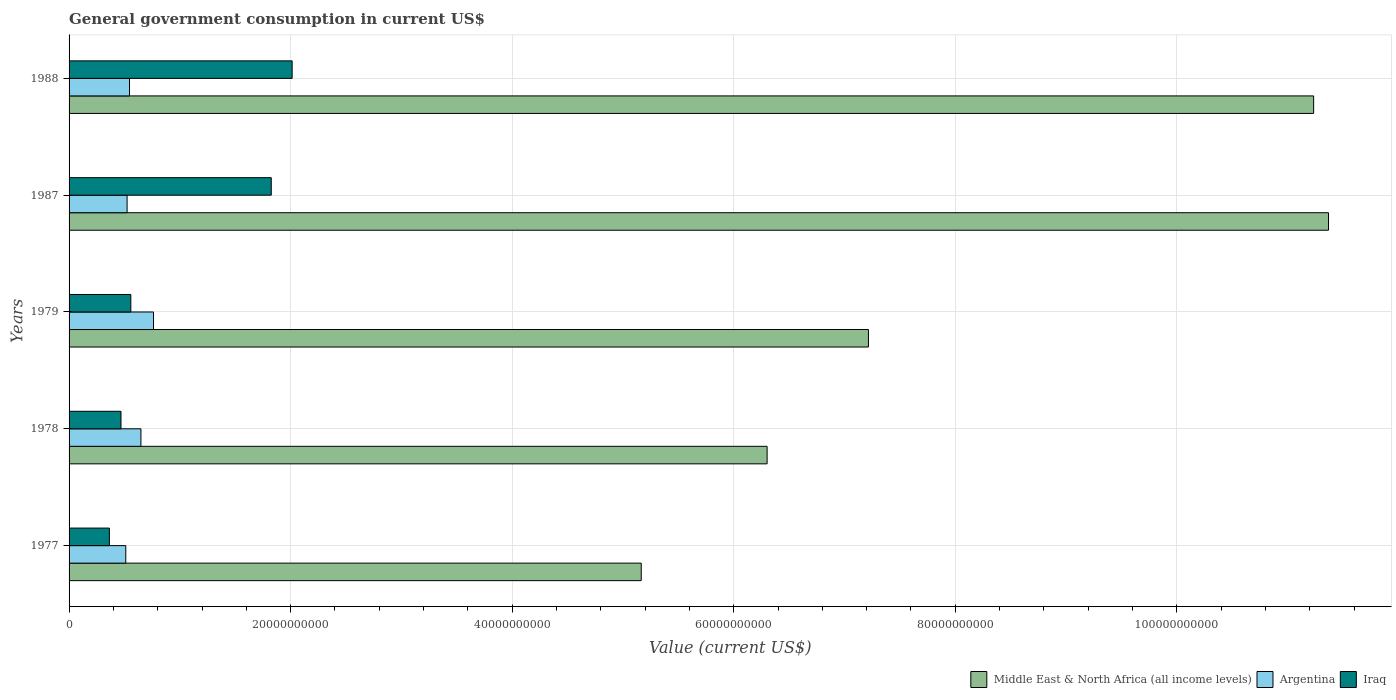How many different coloured bars are there?
Your answer should be compact. 3. Are the number of bars on each tick of the Y-axis equal?
Your response must be concise. Yes. How many bars are there on the 1st tick from the bottom?
Keep it short and to the point. 3. What is the label of the 3rd group of bars from the top?
Your answer should be very brief. 1979. In how many cases, is the number of bars for a given year not equal to the number of legend labels?
Offer a very short reply. 0. What is the government conusmption in Middle East & North Africa (all income levels) in 1978?
Ensure brevity in your answer.  6.30e+1. Across all years, what is the maximum government conusmption in Argentina?
Offer a very short reply. 7.62e+09. Across all years, what is the minimum government conusmption in Iraq?
Provide a succinct answer. 3.64e+09. What is the total government conusmption in Iraq in the graph?
Offer a very short reply. 5.23e+1. What is the difference between the government conusmption in Argentina in 1978 and that in 1987?
Give a very brief answer. 1.25e+09. What is the difference between the government conusmption in Iraq in 1988 and the government conusmption in Argentina in 1977?
Ensure brevity in your answer.  1.50e+1. What is the average government conusmption in Argentina per year?
Make the answer very short. 5.98e+09. In the year 1987, what is the difference between the government conusmption in Middle East & North Africa (all income levels) and government conusmption in Iraq?
Provide a short and direct response. 9.54e+1. What is the ratio of the government conusmption in Argentina in 1978 to that in 1987?
Your response must be concise. 1.24. What is the difference between the highest and the second highest government conusmption in Middle East & North Africa (all income levels)?
Ensure brevity in your answer.  1.34e+09. What is the difference between the highest and the lowest government conusmption in Middle East & North Africa (all income levels)?
Ensure brevity in your answer.  6.20e+1. In how many years, is the government conusmption in Iraq greater than the average government conusmption in Iraq taken over all years?
Provide a succinct answer. 2. What does the 3rd bar from the top in 1978 represents?
Your response must be concise. Middle East & North Africa (all income levels). What does the 3rd bar from the bottom in 1988 represents?
Offer a very short reply. Iraq. How many bars are there?
Provide a succinct answer. 15. How many years are there in the graph?
Offer a terse response. 5. Are the values on the major ticks of X-axis written in scientific E-notation?
Your answer should be very brief. No. How many legend labels are there?
Offer a very short reply. 3. What is the title of the graph?
Offer a terse response. General government consumption in current US$. Does "Ecuador" appear as one of the legend labels in the graph?
Keep it short and to the point. No. What is the label or title of the X-axis?
Give a very brief answer. Value (current US$). What is the label or title of the Y-axis?
Your response must be concise. Years. What is the Value (current US$) of Middle East & North Africa (all income levels) in 1977?
Offer a terse response. 5.17e+1. What is the Value (current US$) of Argentina in 1977?
Provide a short and direct response. 5.12e+09. What is the Value (current US$) in Iraq in 1977?
Your answer should be very brief. 3.64e+09. What is the Value (current US$) of Middle East & North Africa (all income levels) in 1978?
Your response must be concise. 6.30e+1. What is the Value (current US$) in Argentina in 1978?
Ensure brevity in your answer.  6.49e+09. What is the Value (current US$) of Iraq in 1978?
Offer a terse response. 4.69e+09. What is the Value (current US$) of Middle East & North Africa (all income levels) in 1979?
Provide a succinct answer. 7.22e+1. What is the Value (current US$) in Argentina in 1979?
Your response must be concise. 7.62e+09. What is the Value (current US$) in Iraq in 1979?
Provide a succinct answer. 5.58e+09. What is the Value (current US$) in Middle East & North Africa (all income levels) in 1987?
Give a very brief answer. 1.14e+11. What is the Value (current US$) in Argentina in 1987?
Provide a short and direct response. 5.24e+09. What is the Value (current US$) of Iraq in 1987?
Your answer should be very brief. 1.83e+1. What is the Value (current US$) of Middle East & North Africa (all income levels) in 1988?
Your response must be concise. 1.12e+11. What is the Value (current US$) in Argentina in 1988?
Give a very brief answer. 5.45e+09. What is the Value (current US$) of Iraq in 1988?
Keep it short and to the point. 2.01e+1. Across all years, what is the maximum Value (current US$) of Middle East & North Africa (all income levels)?
Your answer should be compact. 1.14e+11. Across all years, what is the maximum Value (current US$) in Argentina?
Your answer should be compact. 7.62e+09. Across all years, what is the maximum Value (current US$) of Iraq?
Provide a succinct answer. 2.01e+1. Across all years, what is the minimum Value (current US$) of Middle East & North Africa (all income levels)?
Provide a succinct answer. 5.17e+1. Across all years, what is the minimum Value (current US$) in Argentina?
Offer a terse response. 5.12e+09. Across all years, what is the minimum Value (current US$) in Iraq?
Ensure brevity in your answer.  3.64e+09. What is the total Value (current US$) of Middle East & North Africa (all income levels) in the graph?
Keep it short and to the point. 4.13e+11. What is the total Value (current US$) in Argentina in the graph?
Offer a terse response. 2.99e+1. What is the total Value (current US$) of Iraq in the graph?
Give a very brief answer. 5.23e+1. What is the difference between the Value (current US$) of Middle East & North Africa (all income levels) in 1977 and that in 1978?
Make the answer very short. -1.14e+1. What is the difference between the Value (current US$) in Argentina in 1977 and that in 1978?
Ensure brevity in your answer.  -1.37e+09. What is the difference between the Value (current US$) in Iraq in 1977 and that in 1978?
Provide a succinct answer. -1.05e+09. What is the difference between the Value (current US$) in Middle East & North Africa (all income levels) in 1977 and that in 1979?
Offer a terse response. -2.05e+1. What is the difference between the Value (current US$) in Argentina in 1977 and that in 1979?
Give a very brief answer. -2.50e+09. What is the difference between the Value (current US$) in Iraq in 1977 and that in 1979?
Provide a succinct answer. -1.94e+09. What is the difference between the Value (current US$) of Middle East & North Africa (all income levels) in 1977 and that in 1987?
Keep it short and to the point. -6.20e+1. What is the difference between the Value (current US$) of Argentina in 1977 and that in 1987?
Offer a terse response. -1.19e+08. What is the difference between the Value (current US$) in Iraq in 1977 and that in 1987?
Make the answer very short. -1.46e+1. What is the difference between the Value (current US$) in Middle East & North Africa (all income levels) in 1977 and that in 1988?
Ensure brevity in your answer.  -6.07e+1. What is the difference between the Value (current US$) of Argentina in 1977 and that in 1988?
Provide a succinct answer. -3.36e+08. What is the difference between the Value (current US$) in Iraq in 1977 and that in 1988?
Keep it short and to the point. -1.65e+1. What is the difference between the Value (current US$) in Middle East & North Africa (all income levels) in 1978 and that in 1979?
Offer a very short reply. -9.15e+09. What is the difference between the Value (current US$) of Argentina in 1978 and that in 1979?
Your response must be concise. -1.14e+09. What is the difference between the Value (current US$) of Iraq in 1978 and that in 1979?
Your response must be concise. -8.88e+08. What is the difference between the Value (current US$) in Middle East & North Africa (all income levels) in 1978 and that in 1987?
Keep it short and to the point. -5.07e+1. What is the difference between the Value (current US$) in Argentina in 1978 and that in 1987?
Make the answer very short. 1.25e+09. What is the difference between the Value (current US$) in Iraq in 1978 and that in 1987?
Make the answer very short. -1.36e+1. What is the difference between the Value (current US$) of Middle East & North Africa (all income levels) in 1978 and that in 1988?
Provide a short and direct response. -4.93e+1. What is the difference between the Value (current US$) in Argentina in 1978 and that in 1988?
Make the answer very short. 1.03e+09. What is the difference between the Value (current US$) of Iraq in 1978 and that in 1988?
Provide a succinct answer. -1.55e+1. What is the difference between the Value (current US$) of Middle East & North Africa (all income levels) in 1979 and that in 1987?
Provide a succinct answer. -4.15e+1. What is the difference between the Value (current US$) in Argentina in 1979 and that in 1987?
Keep it short and to the point. 2.39e+09. What is the difference between the Value (current US$) in Iraq in 1979 and that in 1987?
Make the answer very short. -1.27e+1. What is the difference between the Value (current US$) of Middle East & North Africa (all income levels) in 1979 and that in 1988?
Your answer should be very brief. -4.02e+1. What is the difference between the Value (current US$) of Argentina in 1979 and that in 1988?
Give a very brief answer. 2.17e+09. What is the difference between the Value (current US$) in Iraq in 1979 and that in 1988?
Ensure brevity in your answer.  -1.46e+1. What is the difference between the Value (current US$) in Middle East & North Africa (all income levels) in 1987 and that in 1988?
Provide a succinct answer. 1.34e+09. What is the difference between the Value (current US$) of Argentina in 1987 and that in 1988?
Your answer should be very brief. -2.16e+08. What is the difference between the Value (current US$) of Iraq in 1987 and that in 1988?
Your answer should be very brief. -1.89e+09. What is the difference between the Value (current US$) in Middle East & North Africa (all income levels) in 1977 and the Value (current US$) in Argentina in 1978?
Offer a very short reply. 4.52e+1. What is the difference between the Value (current US$) of Middle East & North Africa (all income levels) in 1977 and the Value (current US$) of Iraq in 1978?
Provide a short and direct response. 4.70e+1. What is the difference between the Value (current US$) of Argentina in 1977 and the Value (current US$) of Iraq in 1978?
Provide a short and direct response. 4.32e+08. What is the difference between the Value (current US$) of Middle East & North Africa (all income levels) in 1977 and the Value (current US$) of Argentina in 1979?
Your response must be concise. 4.40e+1. What is the difference between the Value (current US$) of Middle East & North Africa (all income levels) in 1977 and the Value (current US$) of Iraq in 1979?
Offer a terse response. 4.61e+1. What is the difference between the Value (current US$) in Argentina in 1977 and the Value (current US$) in Iraq in 1979?
Offer a terse response. -4.56e+08. What is the difference between the Value (current US$) in Middle East & North Africa (all income levels) in 1977 and the Value (current US$) in Argentina in 1987?
Offer a terse response. 4.64e+1. What is the difference between the Value (current US$) of Middle East & North Africa (all income levels) in 1977 and the Value (current US$) of Iraq in 1987?
Your answer should be compact. 3.34e+1. What is the difference between the Value (current US$) in Argentina in 1977 and the Value (current US$) in Iraq in 1987?
Provide a succinct answer. -1.31e+1. What is the difference between the Value (current US$) in Middle East & North Africa (all income levels) in 1977 and the Value (current US$) in Argentina in 1988?
Your response must be concise. 4.62e+1. What is the difference between the Value (current US$) in Middle East & North Africa (all income levels) in 1977 and the Value (current US$) in Iraq in 1988?
Offer a very short reply. 3.15e+1. What is the difference between the Value (current US$) in Argentina in 1977 and the Value (current US$) in Iraq in 1988?
Keep it short and to the point. -1.50e+1. What is the difference between the Value (current US$) in Middle East & North Africa (all income levels) in 1978 and the Value (current US$) in Argentina in 1979?
Make the answer very short. 5.54e+1. What is the difference between the Value (current US$) in Middle East & North Africa (all income levels) in 1978 and the Value (current US$) in Iraq in 1979?
Keep it short and to the point. 5.74e+1. What is the difference between the Value (current US$) in Argentina in 1978 and the Value (current US$) in Iraq in 1979?
Your answer should be compact. 9.11e+08. What is the difference between the Value (current US$) in Middle East & North Africa (all income levels) in 1978 and the Value (current US$) in Argentina in 1987?
Your response must be concise. 5.78e+1. What is the difference between the Value (current US$) in Middle East & North Africa (all income levels) in 1978 and the Value (current US$) in Iraq in 1987?
Make the answer very short. 4.48e+1. What is the difference between the Value (current US$) in Argentina in 1978 and the Value (current US$) in Iraq in 1987?
Give a very brief answer. -1.18e+1. What is the difference between the Value (current US$) of Middle East & North Africa (all income levels) in 1978 and the Value (current US$) of Argentina in 1988?
Keep it short and to the point. 5.76e+1. What is the difference between the Value (current US$) of Middle East & North Africa (all income levels) in 1978 and the Value (current US$) of Iraq in 1988?
Provide a short and direct response. 4.29e+1. What is the difference between the Value (current US$) of Argentina in 1978 and the Value (current US$) of Iraq in 1988?
Offer a terse response. -1.37e+1. What is the difference between the Value (current US$) of Middle East & North Africa (all income levels) in 1979 and the Value (current US$) of Argentina in 1987?
Ensure brevity in your answer.  6.69e+1. What is the difference between the Value (current US$) of Middle East & North Africa (all income levels) in 1979 and the Value (current US$) of Iraq in 1987?
Offer a terse response. 5.39e+1. What is the difference between the Value (current US$) in Argentina in 1979 and the Value (current US$) in Iraq in 1987?
Offer a very short reply. -1.06e+1. What is the difference between the Value (current US$) of Middle East & North Africa (all income levels) in 1979 and the Value (current US$) of Argentina in 1988?
Offer a very short reply. 6.67e+1. What is the difference between the Value (current US$) in Middle East & North Africa (all income levels) in 1979 and the Value (current US$) in Iraq in 1988?
Your answer should be compact. 5.20e+1. What is the difference between the Value (current US$) in Argentina in 1979 and the Value (current US$) in Iraq in 1988?
Keep it short and to the point. -1.25e+1. What is the difference between the Value (current US$) of Middle East & North Africa (all income levels) in 1987 and the Value (current US$) of Argentina in 1988?
Offer a very short reply. 1.08e+11. What is the difference between the Value (current US$) of Middle East & North Africa (all income levels) in 1987 and the Value (current US$) of Iraq in 1988?
Offer a very short reply. 9.36e+1. What is the difference between the Value (current US$) of Argentina in 1987 and the Value (current US$) of Iraq in 1988?
Ensure brevity in your answer.  -1.49e+1. What is the average Value (current US$) of Middle East & North Africa (all income levels) per year?
Provide a short and direct response. 8.26e+1. What is the average Value (current US$) in Argentina per year?
Keep it short and to the point. 5.98e+09. What is the average Value (current US$) of Iraq per year?
Give a very brief answer. 1.05e+1. In the year 1977, what is the difference between the Value (current US$) in Middle East & North Africa (all income levels) and Value (current US$) in Argentina?
Offer a very short reply. 4.65e+1. In the year 1977, what is the difference between the Value (current US$) in Middle East & North Africa (all income levels) and Value (current US$) in Iraq?
Ensure brevity in your answer.  4.80e+1. In the year 1977, what is the difference between the Value (current US$) of Argentina and Value (current US$) of Iraq?
Your answer should be compact. 1.48e+09. In the year 1978, what is the difference between the Value (current US$) of Middle East & North Africa (all income levels) and Value (current US$) of Argentina?
Give a very brief answer. 5.65e+1. In the year 1978, what is the difference between the Value (current US$) of Middle East & North Africa (all income levels) and Value (current US$) of Iraq?
Your answer should be very brief. 5.83e+1. In the year 1978, what is the difference between the Value (current US$) of Argentina and Value (current US$) of Iraq?
Your response must be concise. 1.80e+09. In the year 1979, what is the difference between the Value (current US$) in Middle East & North Africa (all income levels) and Value (current US$) in Argentina?
Your answer should be very brief. 6.45e+1. In the year 1979, what is the difference between the Value (current US$) of Middle East & North Africa (all income levels) and Value (current US$) of Iraq?
Make the answer very short. 6.66e+1. In the year 1979, what is the difference between the Value (current US$) of Argentina and Value (current US$) of Iraq?
Offer a very short reply. 2.05e+09. In the year 1987, what is the difference between the Value (current US$) in Middle East & North Africa (all income levels) and Value (current US$) in Argentina?
Give a very brief answer. 1.08e+11. In the year 1987, what is the difference between the Value (current US$) of Middle East & North Africa (all income levels) and Value (current US$) of Iraq?
Offer a terse response. 9.54e+1. In the year 1987, what is the difference between the Value (current US$) in Argentina and Value (current US$) in Iraq?
Your response must be concise. -1.30e+1. In the year 1988, what is the difference between the Value (current US$) in Middle East & North Africa (all income levels) and Value (current US$) in Argentina?
Keep it short and to the point. 1.07e+11. In the year 1988, what is the difference between the Value (current US$) of Middle East & North Africa (all income levels) and Value (current US$) of Iraq?
Your answer should be compact. 9.22e+1. In the year 1988, what is the difference between the Value (current US$) in Argentina and Value (current US$) in Iraq?
Keep it short and to the point. -1.47e+1. What is the ratio of the Value (current US$) in Middle East & North Africa (all income levels) in 1977 to that in 1978?
Provide a short and direct response. 0.82. What is the ratio of the Value (current US$) of Argentina in 1977 to that in 1978?
Offer a terse response. 0.79. What is the ratio of the Value (current US$) in Iraq in 1977 to that in 1978?
Make the answer very short. 0.78. What is the ratio of the Value (current US$) in Middle East & North Africa (all income levels) in 1977 to that in 1979?
Offer a very short reply. 0.72. What is the ratio of the Value (current US$) in Argentina in 1977 to that in 1979?
Your answer should be very brief. 0.67. What is the ratio of the Value (current US$) of Iraq in 1977 to that in 1979?
Your response must be concise. 0.65. What is the ratio of the Value (current US$) of Middle East & North Africa (all income levels) in 1977 to that in 1987?
Provide a succinct answer. 0.45. What is the ratio of the Value (current US$) of Argentina in 1977 to that in 1987?
Provide a short and direct response. 0.98. What is the ratio of the Value (current US$) of Iraq in 1977 to that in 1987?
Offer a very short reply. 0.2. What is the ratio of the Value (current US$) of Middle East & North Africa (all income levels) in 1977 to that in 1988?
Your answer should be compact. 0.46. What is the ratio of the Value (current US$) of Argentina in 1977 to that in 1988?
Your answer should be compact. 0.94. What is the ratio of the Value (current US$) in Iraq in 1977 to that in 1988?
Your answer should be compact. 0.18. What is the ratio of the Value (current US$) in Middle East & North Africa (all income levels) in 1978 to that in 1979?
Provide a short and direct response. 0.87. What is the ratio of the Value (current US$) in Argentina in 1978 to that in 1979?
Provide a short and direct response. 0.85. What is the ratio of the Value (current US$) in Iraq in 1978 to that in 1979?
Give a very brief answer. 0.84. What is the ratio of the Value (current US$) in Middle East & North Africa (all income levels) in 1978 to that in 1987?
Keep it short and to the point. 0.55. What is the ratio of the Value (current US$) in Argentina in 1978 to that in 1987?
Provide a succinct answer. 1.24. What is the ratio of the Value (current US$) of Iraq in 1978 to that in 1987?
Your answer should be compact. 0.26. What is the ratio of the Value (current US$) in Middle East & North Africa (all income levels) in 1978 to that in 1988?
Make the answer very short. 0.56. What is the ratio of the Value (current US$) of Argentina in 1978 to that in 1988?
Offer a terse response. 1.19. What is the ratio of the Value (current US$) in Iraq in 1978 to that in 1988?
Provide a succinct answer. 0.23. What is the ratio of the Value (current US$) in Middle East & North Africa (all income levels) in 1979 to that in 1987?
Keep it short and to the point. 0.63. What is the ratio of the Value (current US$) of Argentina in 1979 to that in 1987?
Keep it short and to the point. 1.46. What is the ratio of the Value (current US$) in Iraq in 1979 to that in 1987?
Your response must be concise. 0.31. What is the ratio of the Value (current US$) in Middle East & North Africa (all income levels) in 1979 to that in 1988?
Give a very brief answer. 0.64. What is the ratio of the Value (current US$) in Argentina in 1979 to that in 1988?
Offer a terse response. 1.4. What is the ratio of the Value (current US$) of Iraq in 1979 to that in 1988?
Ensure brevity in your answer.  0.28. What is the ratio of the Value (current US$) of Argentina in 1987 to that in 1988?
Ensure brevity in your answer.  0.96. What is the ratio of the Value (current US$) of Iraq in 1987 to that in 1988?
Offer a very short reply. 0.91. What is the difference between the highest and the second highest Value (current US$) in Middle East & North Africa (all income levels)?
Make the answer very short. 1.34e+09. What is the difference between the highest and the second highest Value (current US$) of Argentina?
Keep it short and to the point. 1.14e+09. What is the difference between the highest and the second highest Value (current US$) of Iraq?
Keep it short and to the point. 1.89e+09. What is the difference between the highest and the lowest Value (current US$) in Middle East & North Africa (all income levels)?
Offer a very short reply. 6.20e+1. What is the difference between the highest and the lowest Value (current US$) of Argentina?
Give a very brief answer. 2.50e+09. What is the difference between the highest and the lowest Value (current US$) of Iraq?
Offer a terse response. 1.65e+1. 